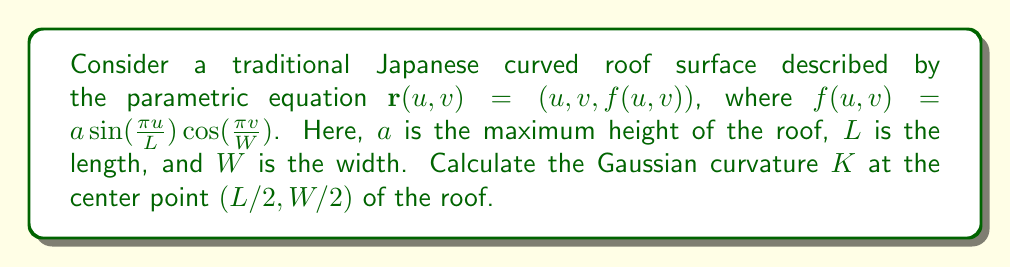Show me your answer to this math problem. To calculate the Gaussian curvature, we need to follow these steps:

1) First, we need to calculate the first fundamental form coefficients:
   $$E = \mathbf{r}_u \cdot \mathbf{r}_u, \quad F = \mathbf{r}_u \cdot \mathbf{r}_v, \quad G = \mathbf{r}_v \cdot \mathbf{r}_v$$

2) Then, we calculate the second fundamental form coefficients:
   $$e = \mathbf{n} \cdot \mathbf{r}_{uu}, \quad f = \mathbf{n} \cdot \mathbf{r}_{uv}, \quad g = \mathbf{n} \cdot \mathbf{r}_{vv}$$
   where $\mathbf{n}$ is the unit normal vector.

3) The Gaussian curvature is given by:
   $$K = \frac{eg-f^2}{EG-F^2}$$

Let's calculate each component:

4) First derivatives:
   $$\mathbf{r}_u = (1, 0, \frac{a\pi}{L}\cos(\frac{\pi u}{L})\cos(\frac{\pi v}{W}))$$
   $$\mathbf{r}_v = (0, 1, -\frac{a\pi}{W}\sin(\frac{\pi u}{L})\sin(\frac{\pi v}{W}))$$

5) Second derivatives:
   $$\mathbf{r}_{uu} = (0, 0, -\frac{a\pi^2}{L^2}\sin(\frac{\pi u}{L})\cos(\frac{\pi v}{W}))$$
   $$\mathbf{r}_{uv} = (0, 0, -\frac{a\pi^2}{LW}\cos(\frac{\pi u}{L})\sin(\frac{\pi v}{W}))$$
   $$\mathbf{r}_{vv} = (0, 0, -\frac{a\pi^2}{W^2}\sin(\frac{\pi u}{L})\cos(\frac{\pi v}{W}))$$

6) At the center point $(L/2, W/2)$:
   $$\mathbf{r}_u = (1, 0, 0), \quad \mathbf{r}_v = (0, 1, 0)$$
   $$\mathbf{r}_{uu} = (0, 0, \frac{a\pi^2}{L^2}), \quad \mathbf{r}_{uv} = (0, 0, 0), \quad \mathbf{r}_{vv} = (0, 0, \frac{a\pi^2}{W^2})$$

7) First fundamental form coefficients:
   $$E = 1, \quad F = 0, \quad G = 1$$

8) Unit normal vector at the center:
   $$\mathbf{n} = (0, 0, 1)$$

9) Second fundamental form coefficients:
   $$e = \frac{a\pi^2}{L^2}, \quad f = 0, \quad g = \frac{a\pi^2}{W^2}$$

10) Substituting into the Gaussian curvature formula:
    $$K = \frac{eg-f^2}{EG-F^2} = \frac{(\frac{a\pi^2}{L^2})(\frac{a\pi^2}{W^2}) - 0^2}{(1)(1) - 0^2} = \frac{a^2\pi^4}{L^2W^2}$$
Answer: $$K = \frac{a^2\pi^4}{L^2W^2}$$ 